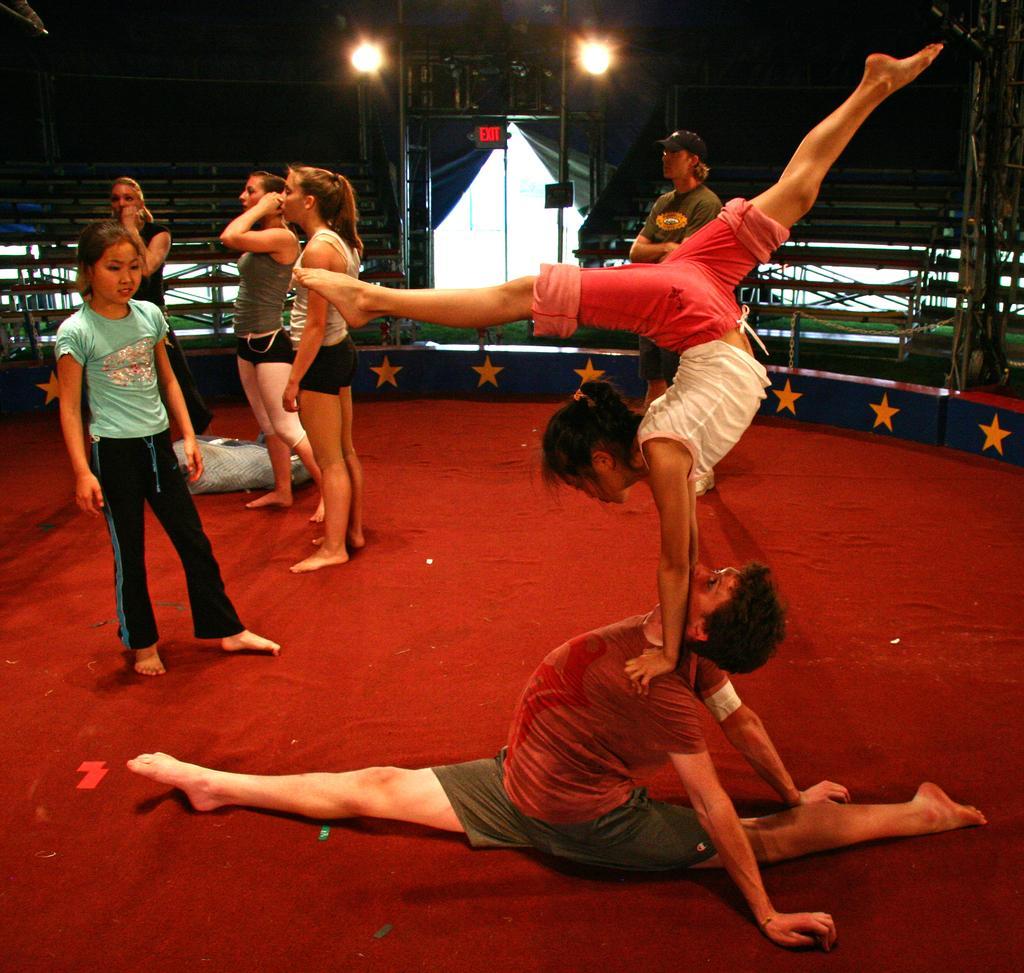Can you describe this image briefly? In this picture, we see two people performing acrobatics. Behind them, there are five people standing on the red carpet. Behind them, we see a white color building and a wooden fence. At the top of the picture, we see street lights and it is dark in the background. 